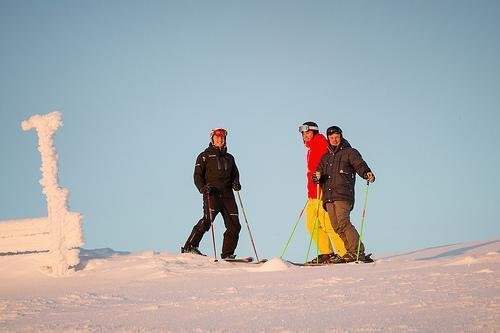How many men are wearing an orange coat?
Give a very brief answer. 1. How many ski poles are visible?
Give a very brief answer. 6. How many men have yellow pants on?
Give a very brief answer. 1. How many skiers are there?
Give a very brief answer. 3. 